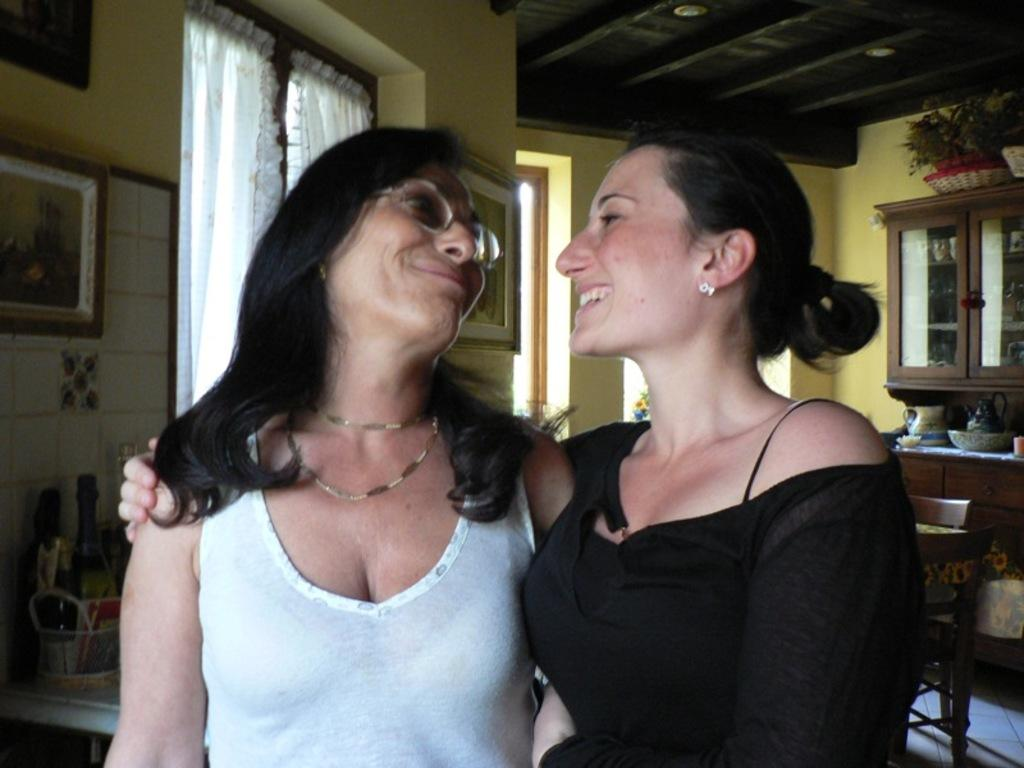How many people are in the image? There are two women in the image. What are the women doing in the image? The women are standing and smiling. What can be seen in the background of the image? There is a wall and a table in the background of the image. What time of day is it in the image? The time of day cannot be determined from the image alone. What is the relation between the two women in the image? The relation between the two women cannot be determined from the image alone. 